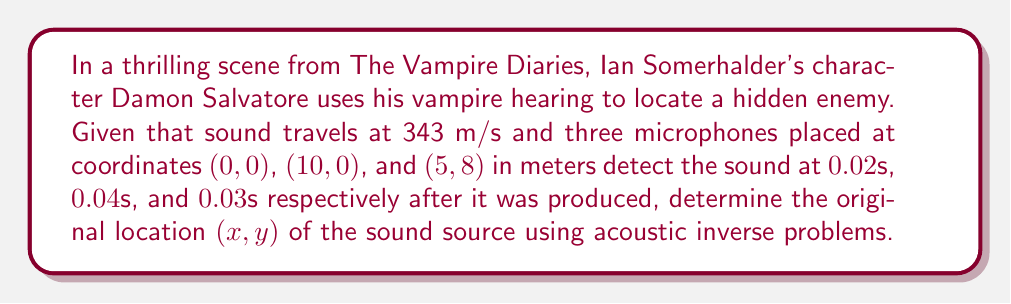Teach me how to tackle this problem. Let's approach this step-by-step using the principles of acoustic inverse problems:

1) Let the unknown sound source location be (x,y).

2) The distance from the sound source to each microphone can be calculated using the time of arrival and speed of sound:
   $$d_i = 343 \cdot t_i$$
   where $d_i$ is the distance to microphone i, and $t_i$ is the time of arrival at microphone i.

3) Calculate the distances:
   $$d_1 = 343 \cdot 0.02 = 6.86\text{ m}$$
   $$d_2 = 343 \cdot 0.04 = 13.72\text{ m}$$
   $$d_3 = 343 \cdot 0.03 = 10.29\text{ m}$$

4) Now, we can set up equations based on the distance formula:
   $$(x-0)^2 + (y-0)^2 = 6.86^2$$
   $$(x-10)^2 + y^2 = 13.72^2$$
   $$(x-5)^2 + (y-8)^2 = 10.29^2$$

5) Expand these equations:
   $$x^2 + y^2 = 47.0596$$
   $$x^2 - 20x + y^2 + 100 = 188.2384$$
   $$x^2 - 10x + y^2 - 16y + 89 = 105.8841$$

6) Subtract the first equation from the second:
   $$-20x + 100 = 141.1788$$
   $$x = 2.9411$$

7) Substitute this x-value into the first equation:
   $$2.9411^2 + y^2 = 47.0596$$
   $$y^2 = 38.4025$$
   $$y = \pm 6.1970$$

8) Check both y values in the third equation to determine the correct one. The positive value satisfies the equation.

Therefore, the sound source location is approximately (2.94, 6.20) meters.
Answer: (2.94, 6.20) m 